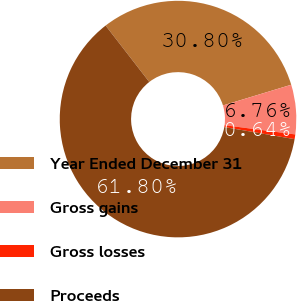Convert chart. <chart><loc_0><loc_0><loc_500><loc_500><pie_chart><fcel>Year Ended December 31<fcel>Gross gains<fcel>Gross losses<fcel>Proceeds<nl><fcel>30.8%<fcel>6.76%<fcel>0.64%<fcel>61.8%<nl></chart> 